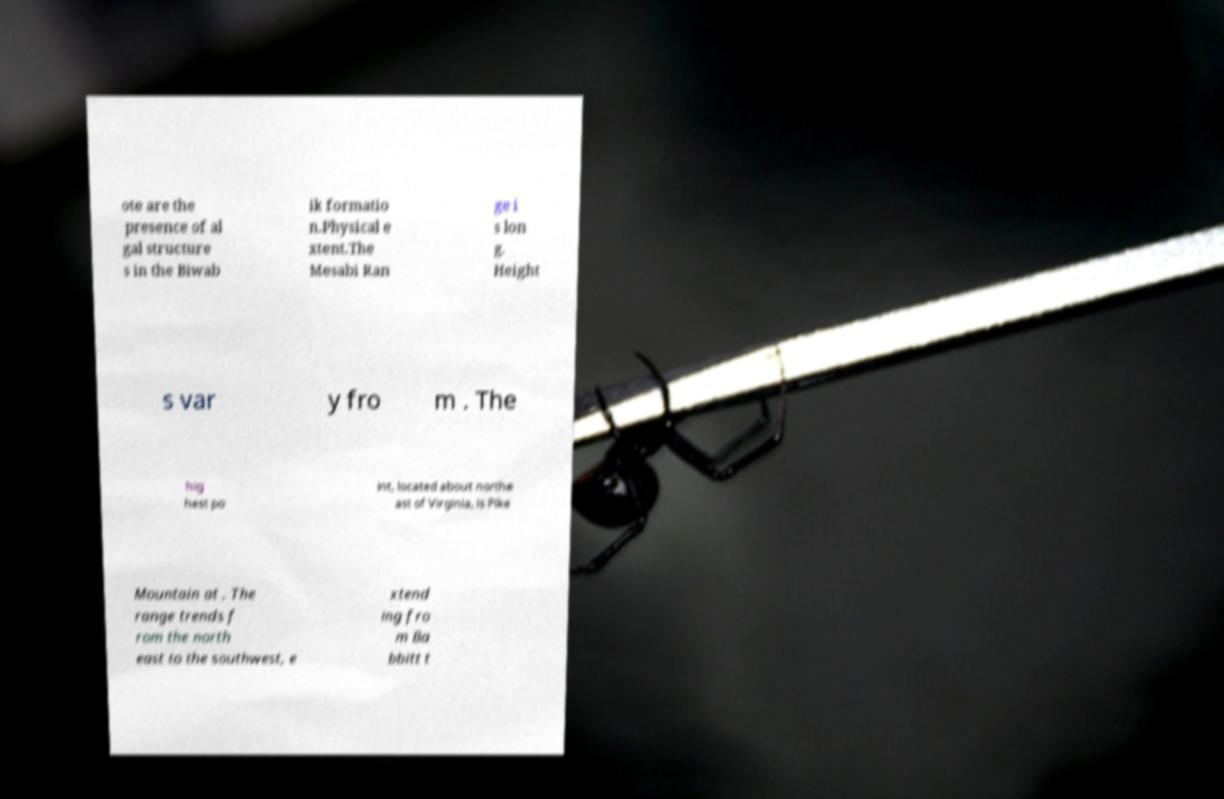Could you assist in decoding the text presented in this image and type it out clearly? ote are the presence of al gal structure s in the Biwab ik formatio n.Physical e xtent.The Mesabi Ran ge i s lon g. Height s var y fro m . The hig hest po int, located about northe ast of Virginia, is Pike Mountain at . The range trends f rom the north east to the southwest, e xtend ing fro m Ba bbitt t 